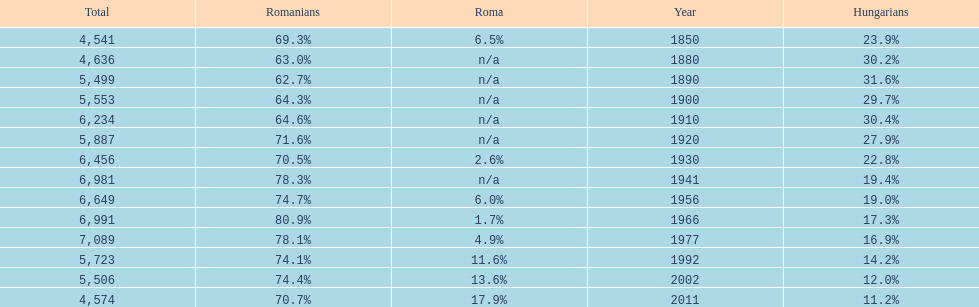What is the number of hungarians in 1850? 23.9%. Can you give me this table as a dict? {'header': ['Total', 'Romanians', 'Roma', 'Year', 'Hungarians'], 'rows': [['4,541', '69.3%', '6.5%', '1850', '23.9%'], ['4,636', '63.0%', 'n/a', '1880', '30.2%'], ['5,499', '62.7%', 'n/a', '1890', '31.6%'], ['5,553', '64.3%', 'n/a', '1900', '29.7%'], ['6,234', '64.6%', 'n/a', '1910', '30.4%'], ['5,887', '71.6%', 'n/a', '1920', '27.9%'], ['6,456', '70.5%', '2.6%', '1930', '22.8%'], ['6,981', '78.3%', 'n/a', '1941', '19.4%'], ['6,649', '74.7%', '6.0%', '1956', '19.0%'], ['6,991', '80.9%', '1.7%', '1966', '17.3%'], ['7,089', '78.1%', '4.9%', '1977', '16.9%'], ['5,723', '74.1%', '11.6%', '1992', '14.2%'], ['5,506', '74.4%', '13.6%', '2002', '12.0%'], ['4,574', '70.7%', '17.9%', '2011', '11.2%']]} 